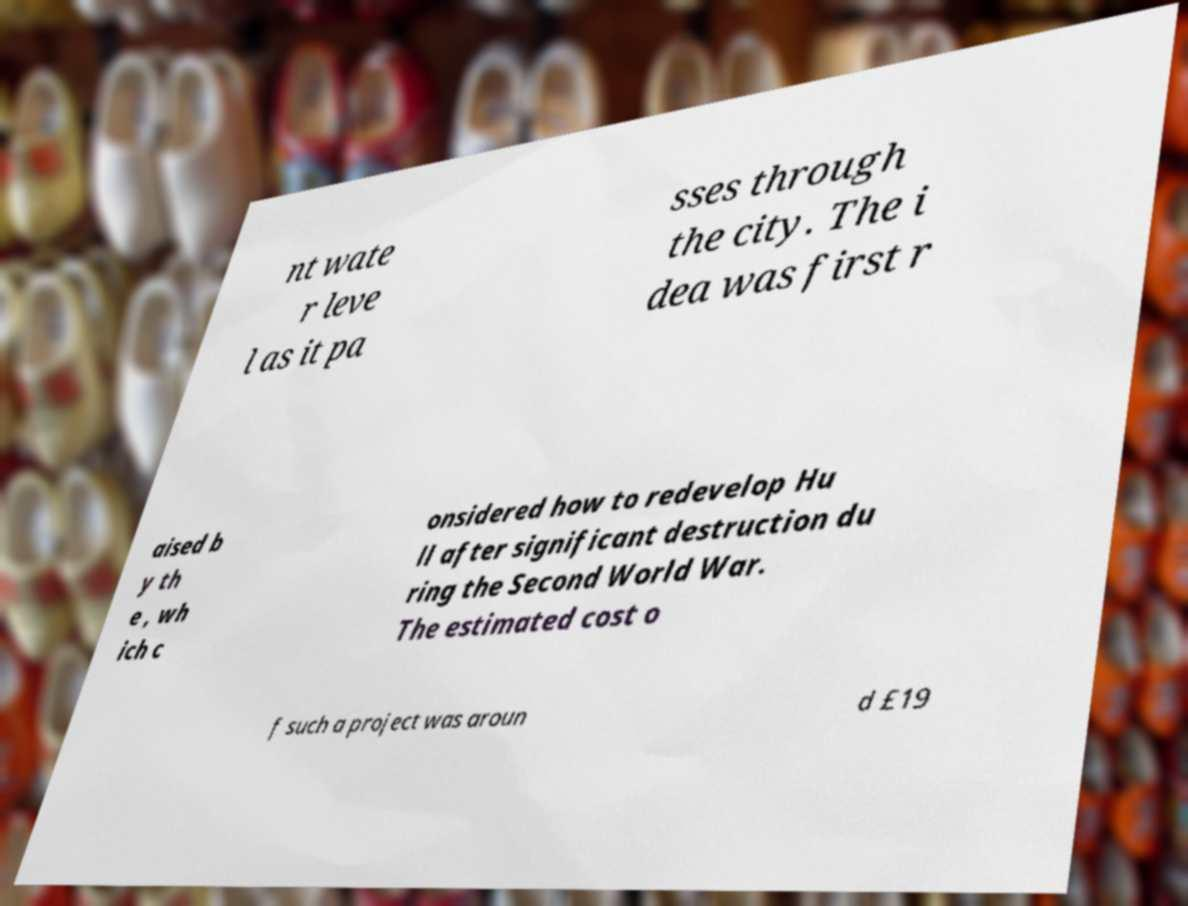Please identify and transcribe the text found in this image. nt wate r leve l as it pa sses through the city. The i dea was first r aised b y th e , wh ich c onsidered how to redevelop Hu ll after significant destruction du ring the Second World War. The estimated cost o f such a project was aroun d £19 